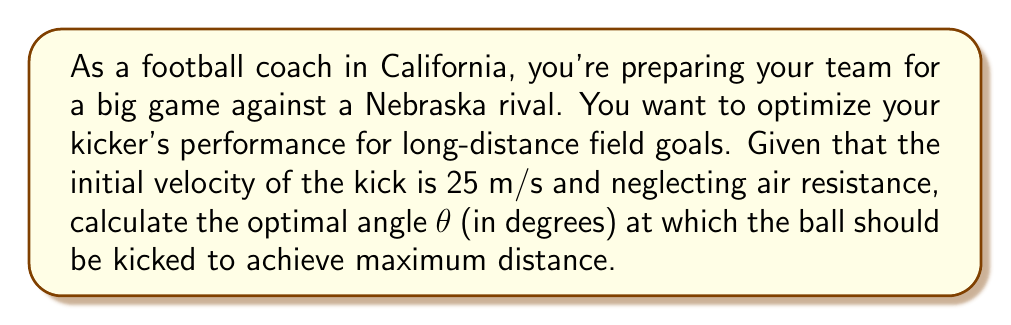Help me with this question. To solve this problem, we need to use principles from projectile motion in physics. The range (R) of a projectile launched from ground level is given by the equation:

$$ R = \frac{v_0^2 \sin(2\theta)}{g} $$

Where:
$v_0$ is the initial velocity
$\theta$ is the launch angle
$g$ is the acceleration due to gravity (approximately 9.8 m/s²)

To find the maximum range, we need to maximize $\sin(2\theta)$. The sine function reaches its maximum value of 1 when its argument is 90°. Therefore:

$$ 2\theta = 90° $$
$$ \theta = 45° $$

This result is independent of the initial velocity and the acceleration due to gravity, making it universally applicable for projectile motion problems without air resistance.

To verify:
$$ R = \frac{(25 \text{ m/s})^2 \sin(2 \cdot 45°)}{9.8 \text{ m/s}^2} $$
$$ R = \frac{625 \text{ m}^2/\text{s}^2 \cdot 1}{9.8 \text{ m/s}^2} $$
$$ R \approx 63.78 \text{ m} $$

This is indeed the maximum distance achievable with the given initial velocity.
Answer: The optimal angle for maximum distance is 45°. 